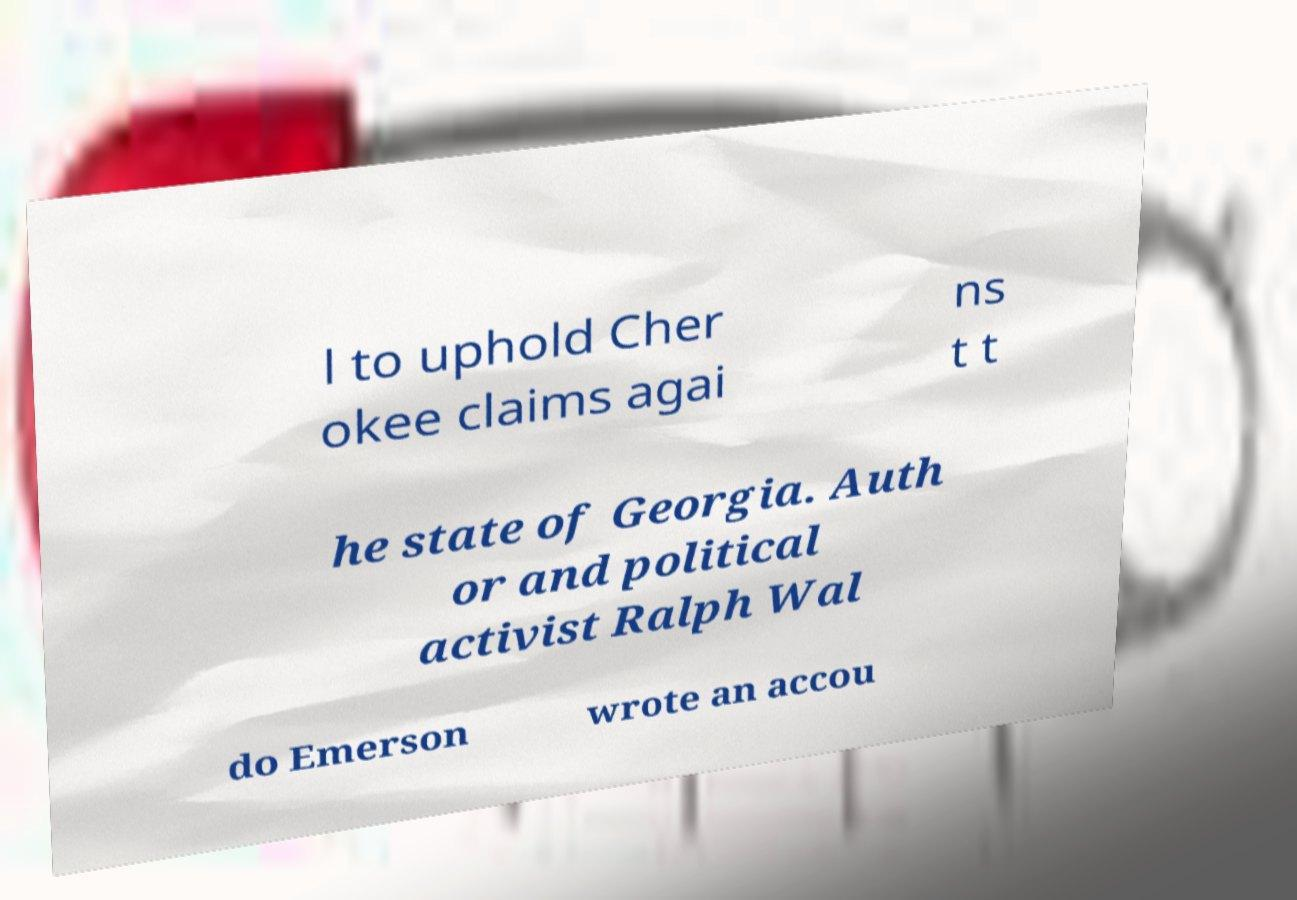I need the written content from this picture converted into text. Can you do that? l to uphold Cher okee claims agai ns t t he state of Georgia. Auth or and political activist Ralph Wal do Emerson wrote an accou 